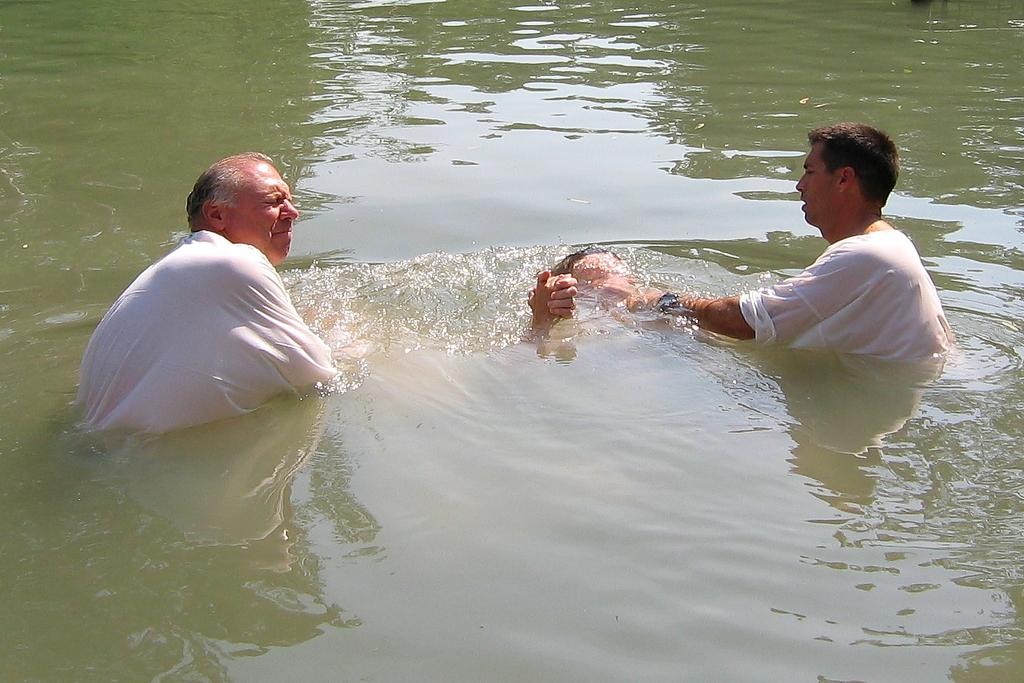What is the primary activity of the people in the image? The people in the image are in the water. Can you describe the setting in which the people are located? The people are in the water, which suggests a swimming or recreational activity. What type of tin can be seen floating in the water? There is no tin present in the image; it only features people in the water. 